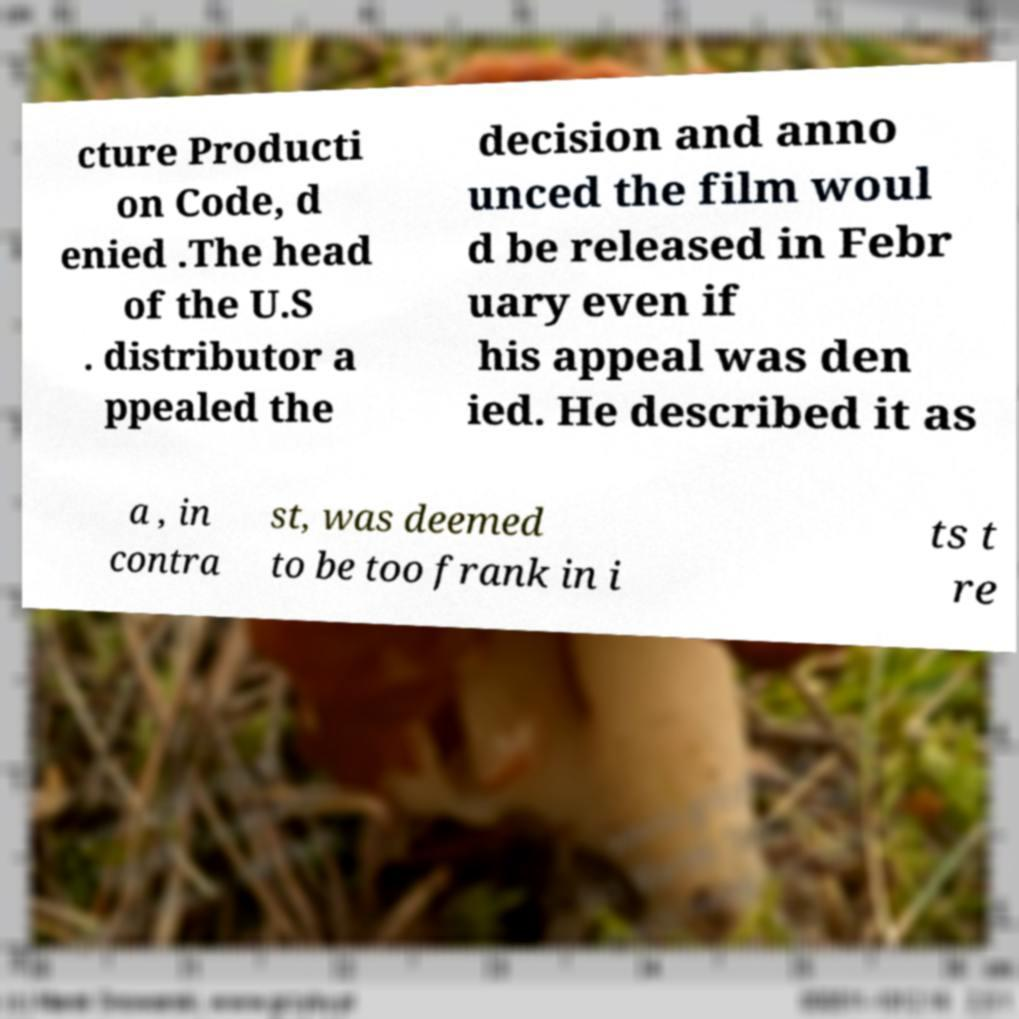Please identify and transcribe the text found in this image. cture Producti on Code, d enied .The head of the U.S . distributor a ppealed the decision and anno unced the film woul d be released in Febr uary even if his appeal was den ied. He described it as a , in contra st, was deemed to be too frank in i ts t re 